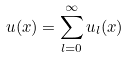<formula> <loc_0><loc_0><loc_500><loc_500>u ( x ) = \sum _ { l = 0 } ^ { \infty } u _ { l } ( x )</formula> 